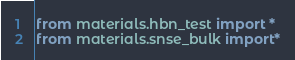Convert code to text. <code><loc_0><loc_0><loc_500><loc_500><_Python_>from materials.hbn_test import *
from materials.snse_bulk import*
</code> 